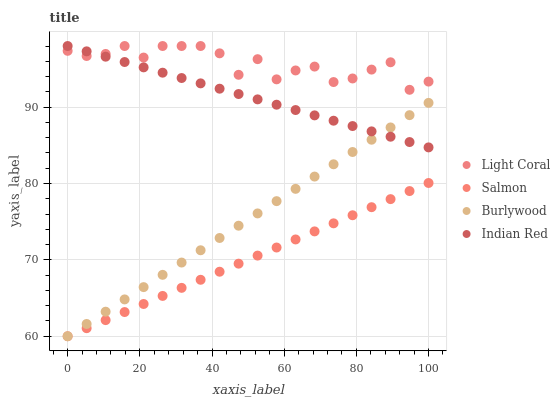Does Salmon have the minimum area under the curve?
Answer yes or no. Yes. Does Light Coral have the maximum area under the curve?
Answer yes or no. Yes. Does Burlywood have the minimum area under the curve?
Answer yes or no. No. Does Burlywood have the maximum area under the curve?
Answer yes or no. No. Is Burlywood the smoothest?
Answer yes or no. Yes. Is Light Coral the roughest?
Answer yes or no. Yes. Is Salmon the smoothest?
Answer yes or no. No. Is Salmon the roughest?
Answer yes or no. No. Does Burlywood have the lowest value?
Answer yes or no. Yes. Does Indian Red have the lowest value?
Answer yes or no. No. Does Indian Red have the highest value?
Answer yes or no. Yes. Does Burlywood have the highest value?
Answer yes or no. No. Is Burlywood less than Light Coral?
Answer yes or no. Yes. Is Indian Red greater than Salmon?
Answer yes or no. Yes. Does Indian Red intersect Light Coral?
Answer yes or no. Yes. Is Indian Red less than Light Coral?
Answer yes or no. No. Is Indian Red greater than Light Coral?
Answer yes or no. No. Does Burlywood intersect Light Coral?
Answer yes or no. No. 